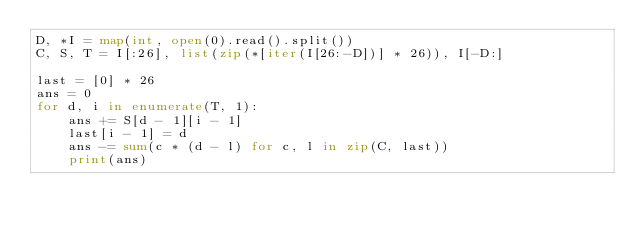Convert code to text. <code><loc_0><loc_0><loc_500><loc_500><_Python_>D, *I = map(int, open(0).read().split())
C, S, T = I[:26], list(zip(*[iter(I[26:-D])] * 26)), I[-D:]

last = [0] * 26
ans = 0
for d, i in enumerate(T, 1):
    ans += S[d - 1][i - 1]
    last[i - 1] = d
    ans -= sum(c * (d - l) for c, l in zip(C, last))
    print(ans)</code> 